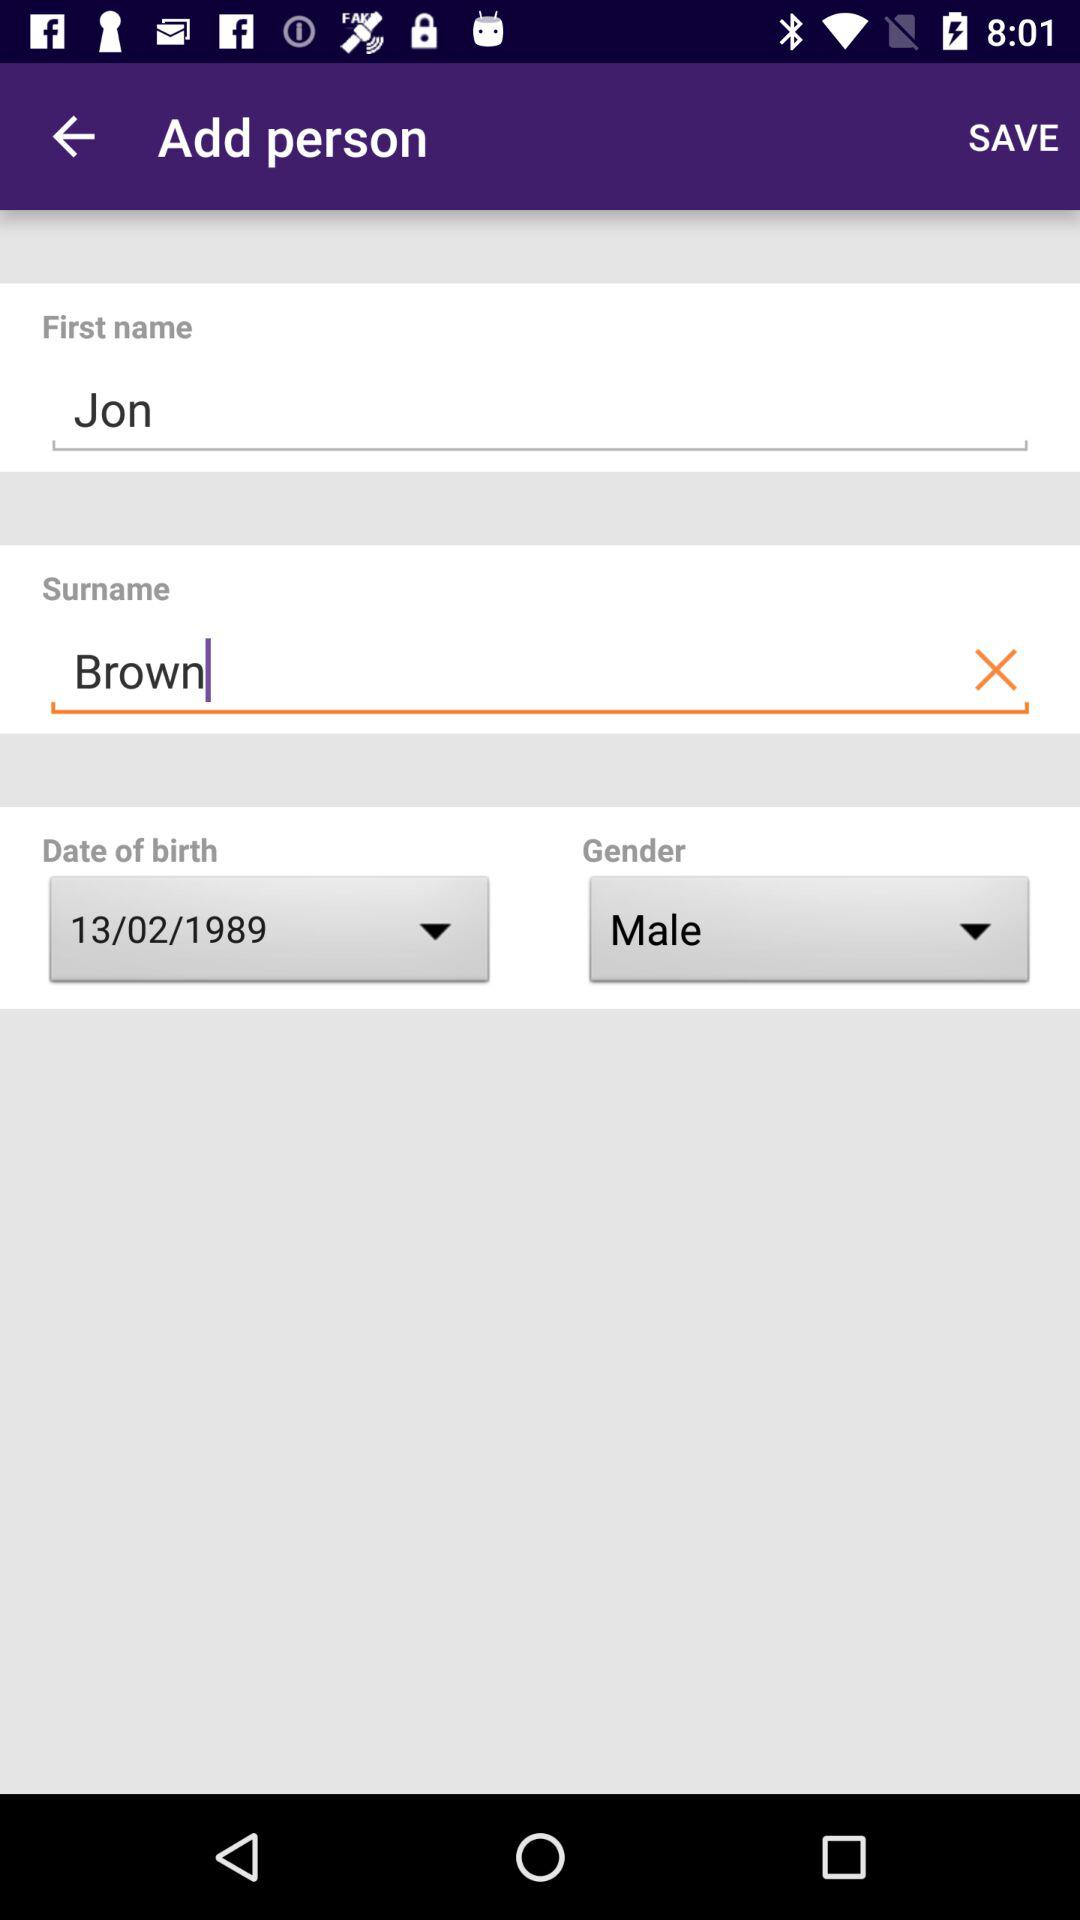What is the date of birth? The date of birth is February 13, 1989. 